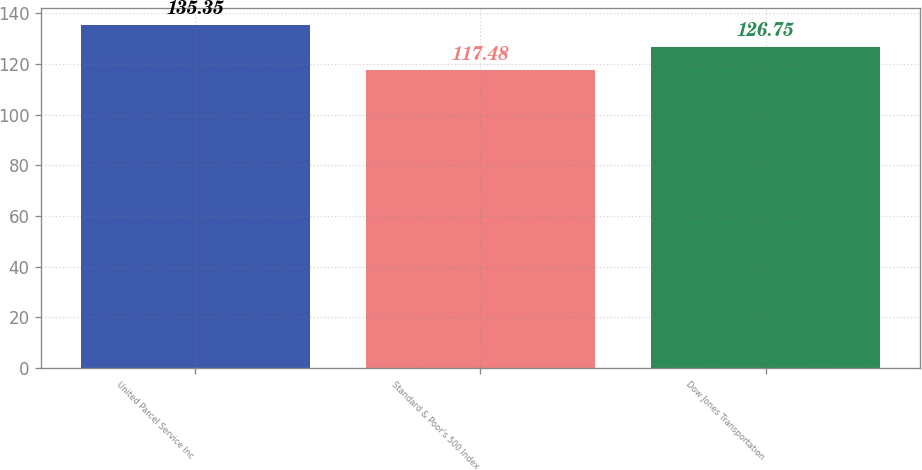<chart> <loc_0><loc_0><loc_500><loc_500><bar_chart><fcel>United Parcel Service Inc<fcel>Standard & Poor's 500 Index<fcel>Dow Jones Transportation<nl><fcel>135.35<fcel>117.48<fcel>126.75<nl></chart> 